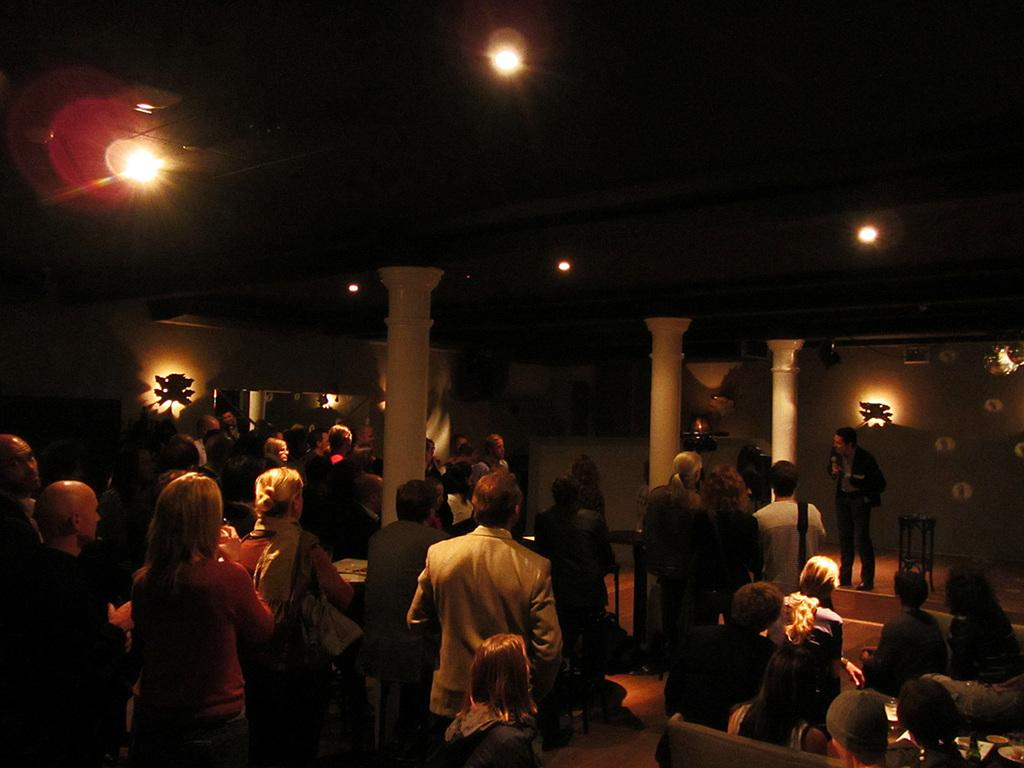What is the position of the man in the image? The man is standing on the right side of the image. What object is next to the man? There is a stool next to the man. How many people are standing in front of the man? There are many people standing in front of the man. What can be seen at the top of the image? There are lights visible at the top of the image. Can you hear the bell ringing in the image? There is no bell present in the image, so it cannot be heard. 